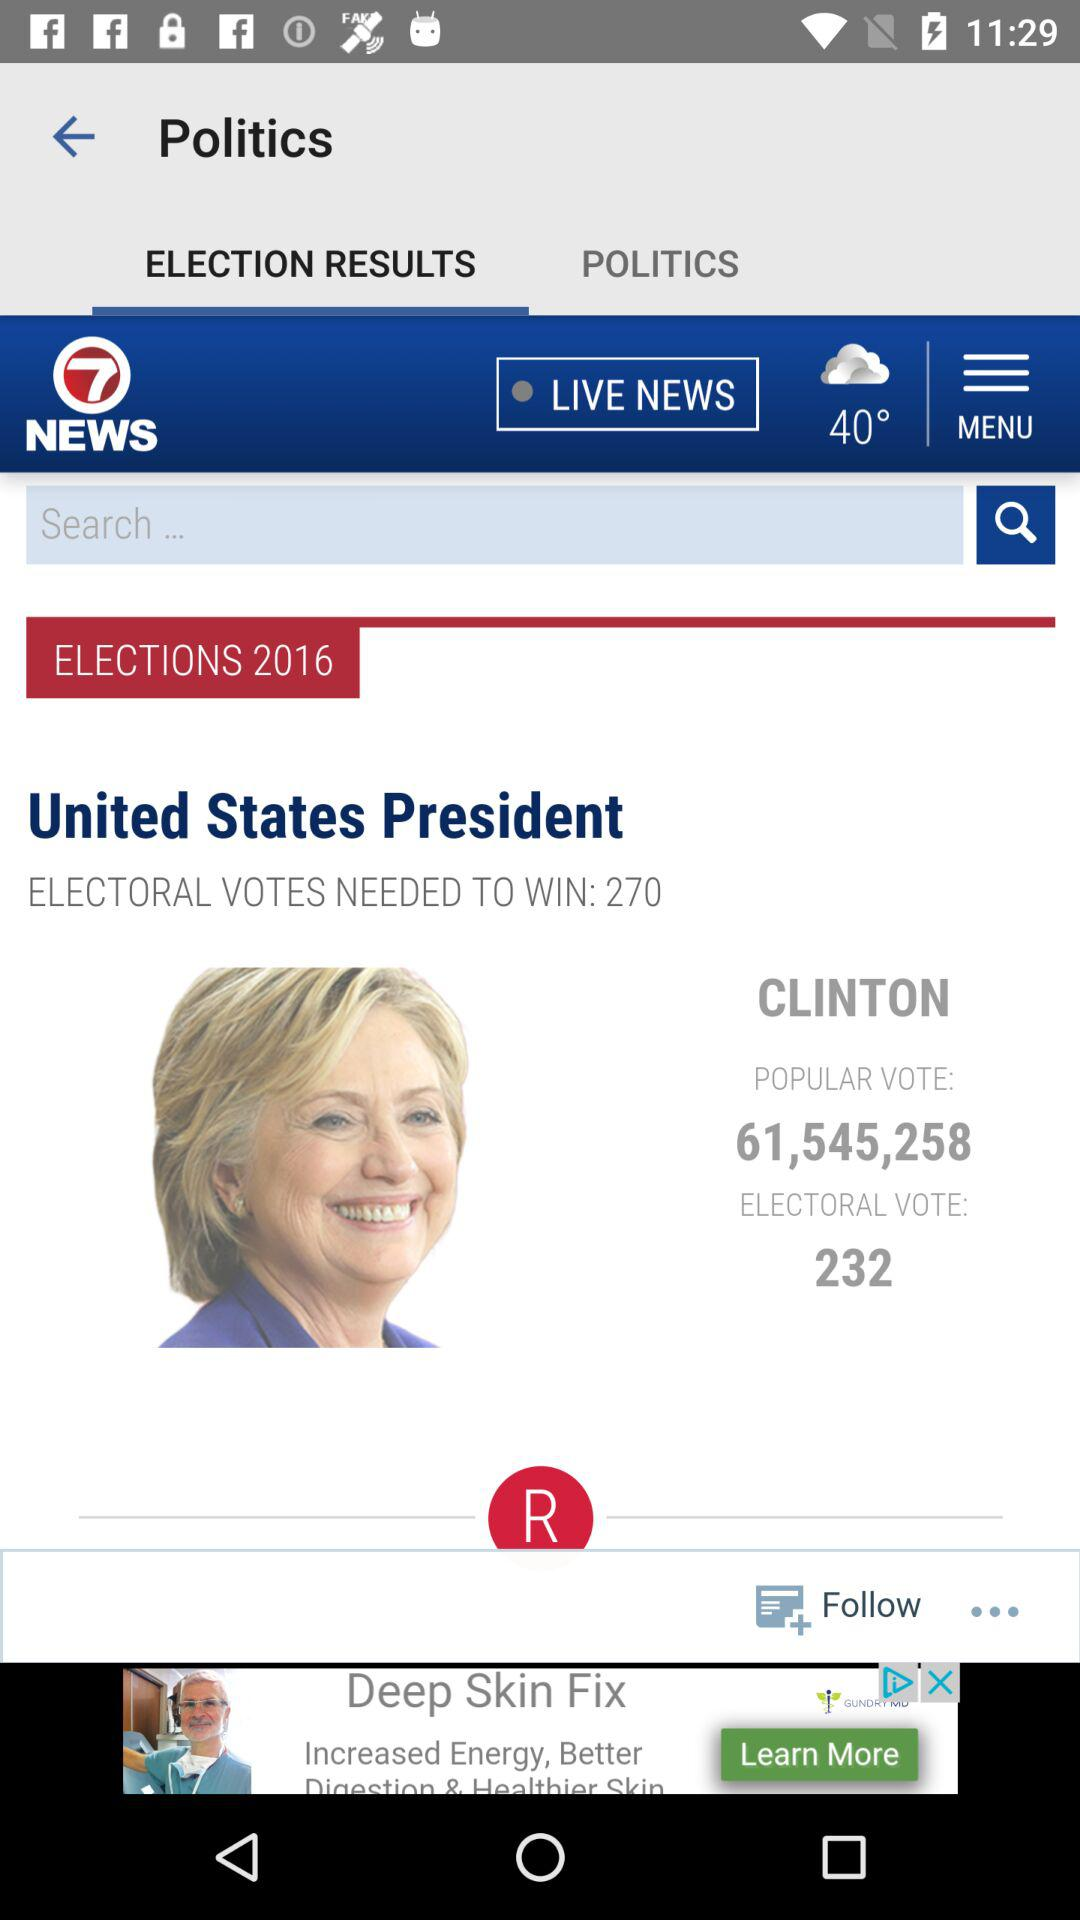How many electoral votes are needed to win? The number of electoral votes needed to win is 270. 